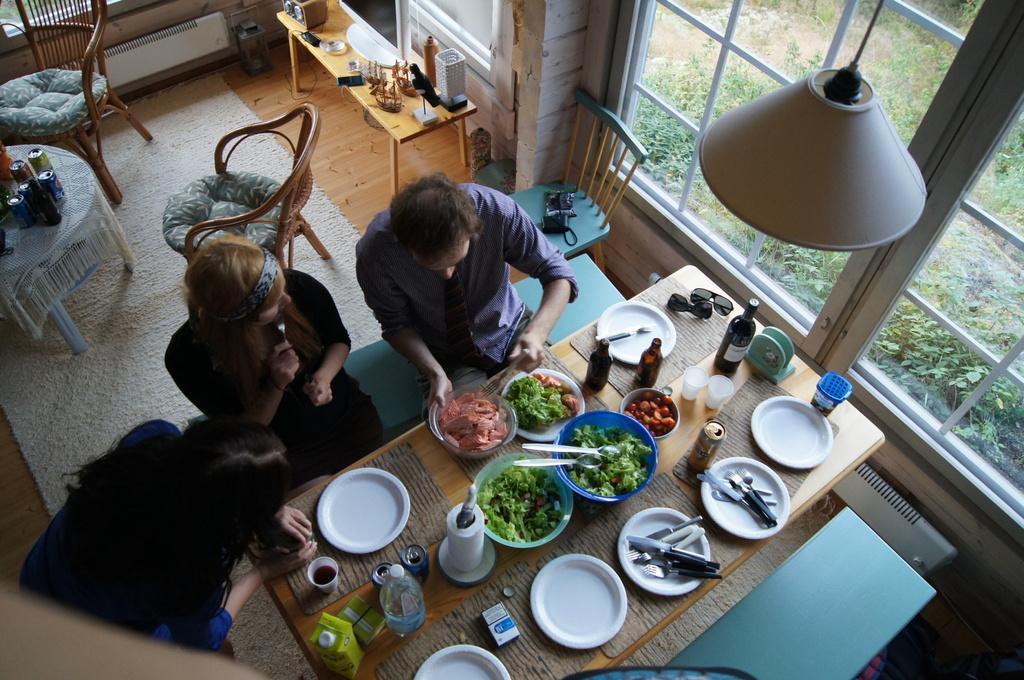In one or two sentences, can you explain what this image depicts? In this image I see 2 women and a man and there is a table in front of them on which there are many things, I can also see the window, chairs, a table and the wall. 